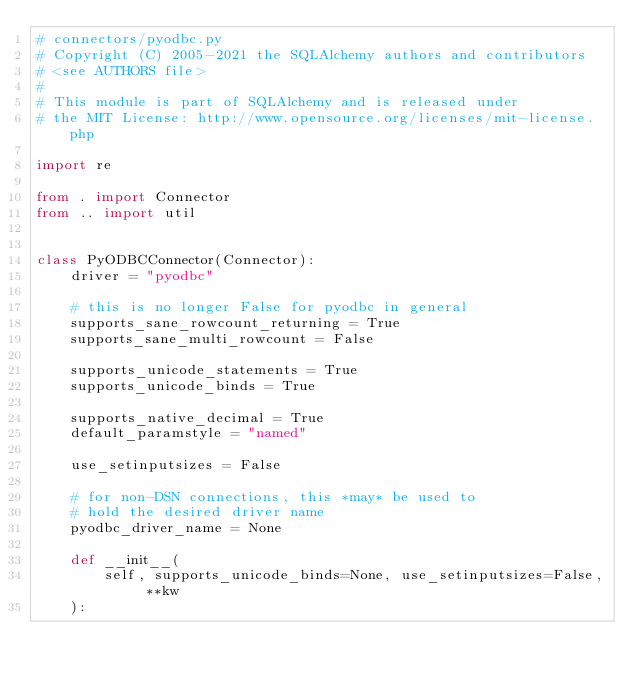Convert code to text. <code><loc_0><loc_0><loc_500><loc_500><_Python_># connectors/pyodbc.py
# Copyright (C) 2005-2021 the SQLAlchemy authors and contributors
# <see AUTHORS file>
#
# This module is part of SQLAlchemy and is released under
# the MIT License: http://www.opensource.org/licenses/mit-license.php

import re

from . import Connector
from .. import util


class PyODBCConnector(Connector):
    driver = "pyodbc"

    # this is no longer False for pyodbc in general
    supports_sane_rowcount_returning = True
    supports_sane_multi_rowcount = False

    supports_unicode_statements = True
    supports_unicode_binds = True

    supports_native_decimal = True
    default_paramstyle = "named"

    use_setinputsizes = False

    # for non-DSN connections, this *may* be used to
    # hold the desired driver name
    pyodbc_driver_name = None

    def __init__(
        self, supports_unicode_binds=None, use_setinputsizes=False, **kw
    ):</code> 